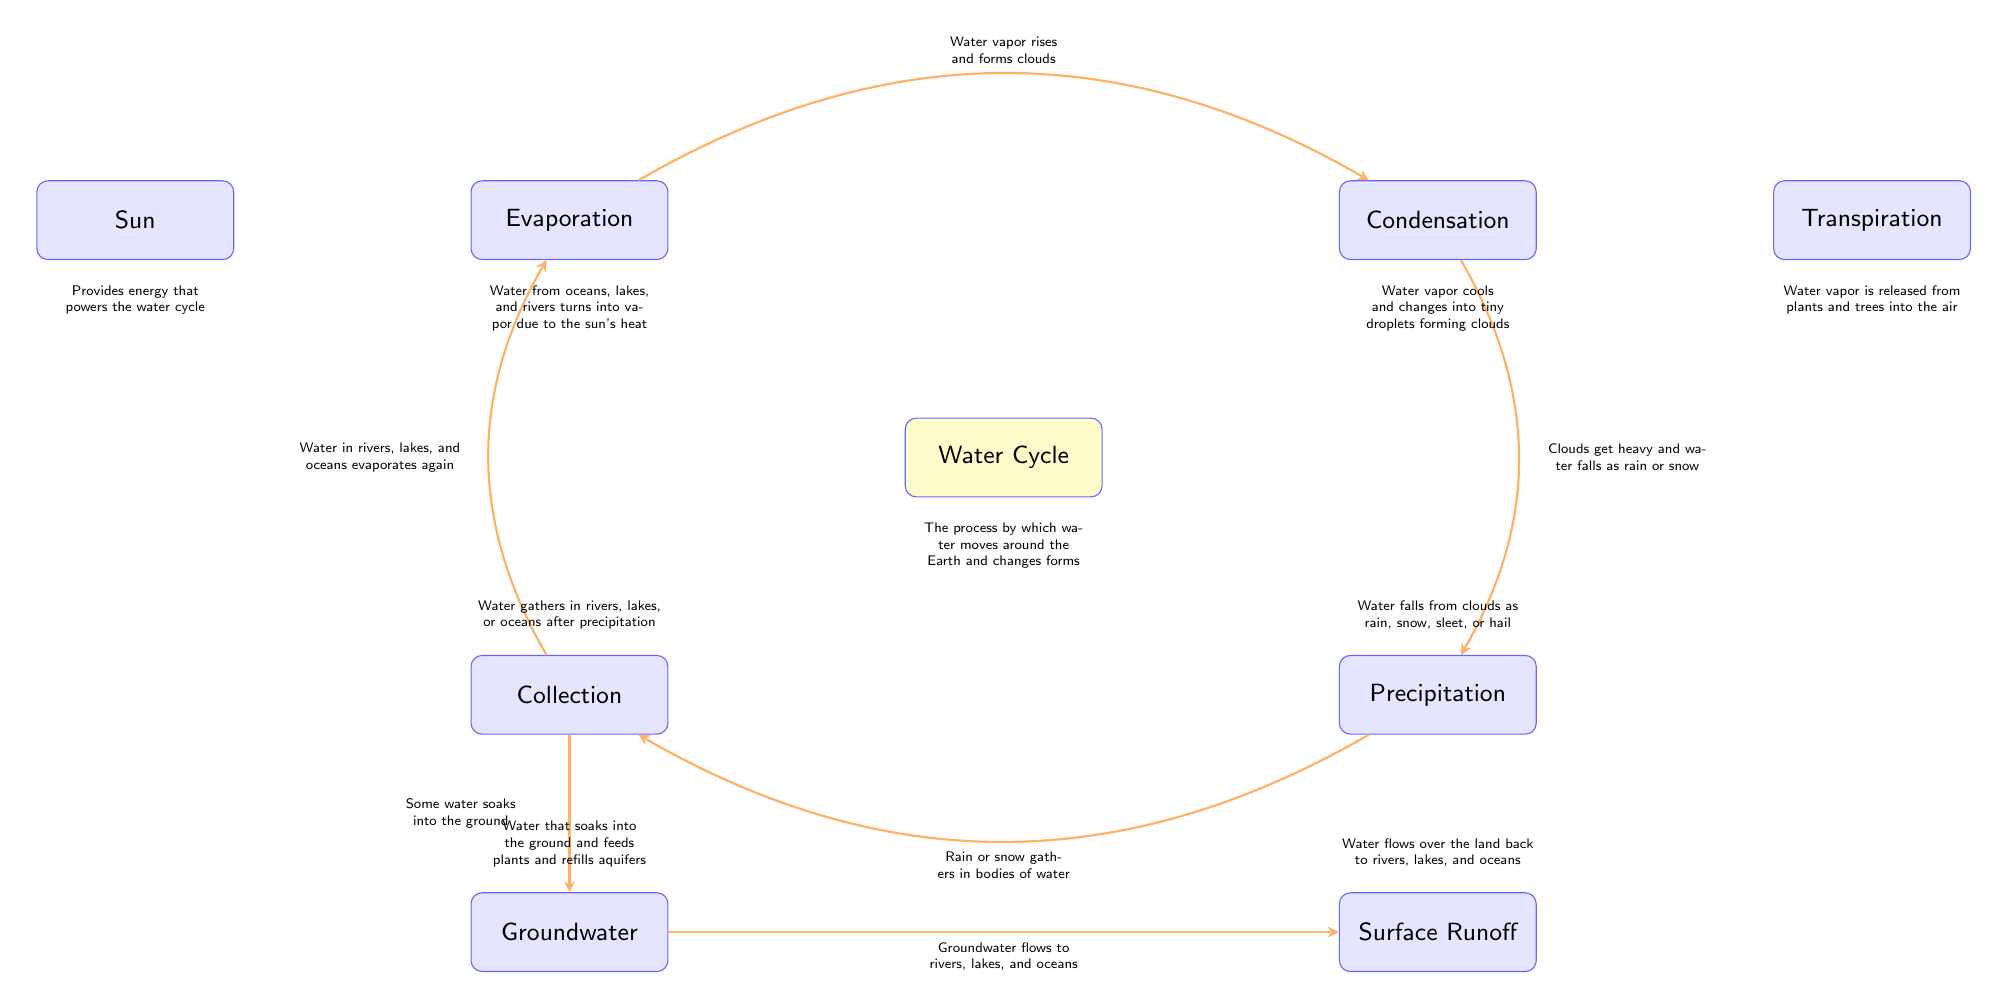What is the central node of the diagram? The central node is labeled "Water Cycle," which is the main focus of the diagram and represents the overall process being illustrated.
Answer: Water Cycle How many processes are involved in the water cycle as shown in the diagram? The diagram shows four main processes: Evaporation, Condensation, Precipitation, and Collection surrounding the central node, indicating a total of four distinct processes.
Answer: 4 What does the sun provide in the water cycle? The diagram states that the sun provides energy that powers the water cycle, highlighting its essential role in initiating the evaporation process.
Answer: Energy What happens during precipitation according to the diagram? Precipitation is described in the diagram as water falling from clouds as rain, snow, sleet, or hail, indicating the different forms in which precipitation can occur.
Answer: Rain, snow, sleet, or hail How does water return to rivers, lakes, and oceans after falling as precipitation? According to the diagram, after precipitation, water gathers in bodies of water, and some water flows over the land back into rivers, lakes, and oceans, depicting the runoff process.
Answer: Surface Runoff What process occurs after condensation? The diagram illustrates that after condensation, clouds become heavy and water falls as precipitation, which is the next step in the water cycle following condensation.
Answer: Precipitation What does the term “transpiration” refer to in the water cycle? Transpiration is described in the diagram as the release of water vapor from plants and trees into the air, highlighting its role as part of the water movement from land back into the atmosphere.
Answer: Water vapor from plants How does groundwater contribute to rivers and lakes? The diagram indicates that groundwater flows to rivers, lakes, and oceans, showing that it is a significant source of water replenishment for these water bodies.
Answer: Flows to rivers, lakes, and oceans What initiates the process of evaporation? The diagram shows that evaporation is initiated by the sun, which heats water in oceans, lakes, and rivers, transforming it into vapor.
Answer: Sun's heat 